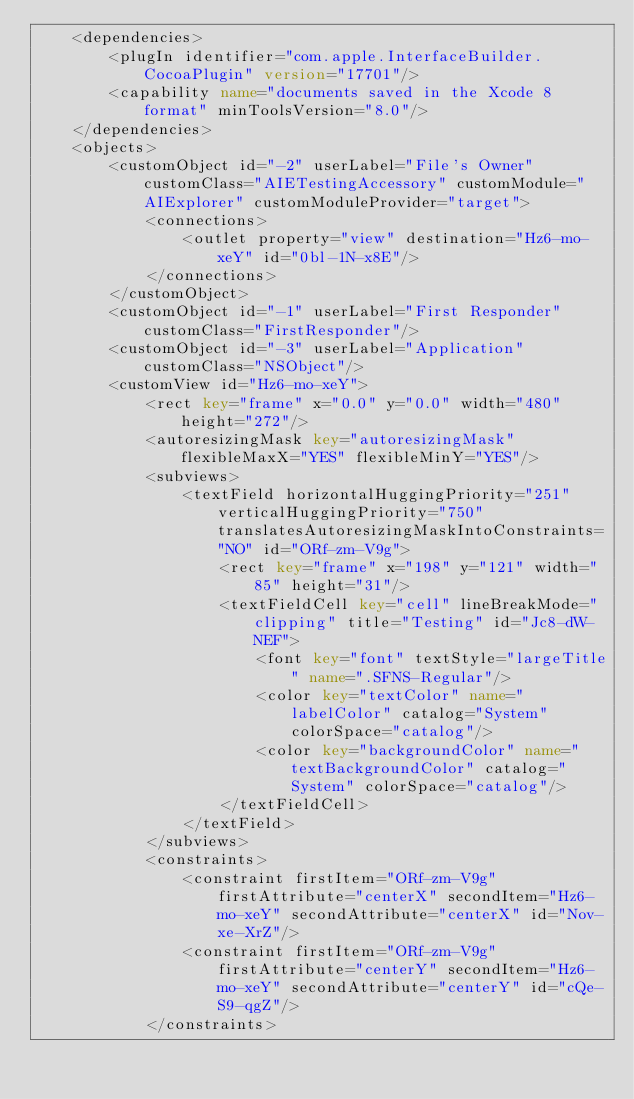Convert code to text. <code><loc_0><loc_0><loc_500><loc_500><_XML_>    <dependencies>
        <plugIn identifier="com.apple.InterfaceBuilder.CocoaPlugin" version="17701"/>
        <capability name="documents saved in the Xcode 8 format" minToolsVersion="8.0"/>
    </dependencies>
    <objects>
        <customObject id="-2" userLabel="File's Owner" customClass="AIETestingAccessory" customModule="AIExplorer" customModuleProvider="target">
            <connections>
                <outlet property="view" destination="Hz6-mo-xeY" id="0bl-1N-x8E"/>
            </connections>
        </customObject>
        <customObject id="-1" userLabel="First Responder" customClass="FirstResponder"/>
        <customObject id="-3" userLabel="Application" customClass="NSObject"/>
        <customView id="Hz6-mo-xeY">
            <rect key="frame" x="0.0" y="0.0" width="480" height="272"/>
            <autoresizingMask key="autoresizingMask" flexibleMaxX="YES" flexibleMinY="YES"/>
            <subviews>
                <textField horizontalHuggingPriority="251" verticalHuggingPriority="750" translatesAutoresizingMaskIntoConstraints="NO" id="ORf-zm-V9g">
                    <rect key="frame" x="198" y="121" width="85" height="31"/>
                    <textFieldCell key="cell" lineBreakMode="clipping" title="Testing" id="Jc8-dW-NEF">
                        <font key="font" textStyle="largeTitle" name=".SFNS-Regular"/>
                        <color key="textColor" name="labelColor" catalog="System" colorSpace="catalog"/>
                        <color key="backgroundColor" name="textBackgroundColor" catalog="System" colorSpace="catalog"/>
                    </textFieldCell>
                </textField>
            </subviews>
            <constraints>
                <constraint firstItem="ORf-zm-V9g" firstAttribute="centerX" secondItem="Hz6-mo-xeY" secondAttribute="centerX" id="Nov-xe-XrZ"/>
                <constraint firstItem="ORf-zm-V9g" firstAttribute="centerY" secondItem="Hz6-mo-xeY" secondAttribute="centerY" id="cQe-S9-qgZ"/>
            </constraints></code> 